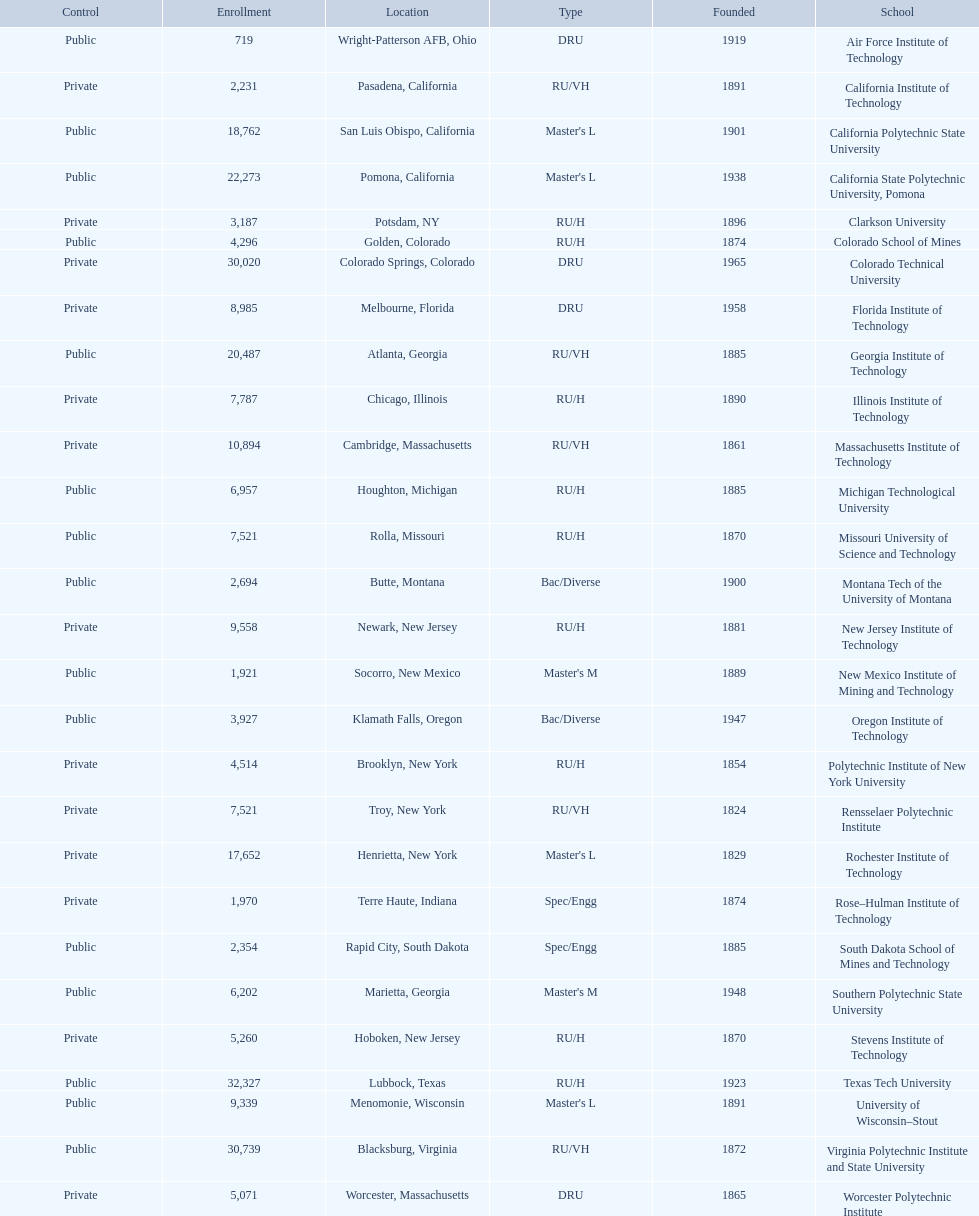What technical universities are in the united states? Air Force Institute of Technology, California Institute of Technology, California Polytechnic State University, California State Polytechnic University, Pomona, Clarkson University, Colorado School of Mines, Colorado Technical University, Florida Institute of Technology, Georgia Institute of Technology, Illinois Institute of Technology, Massachusetts Institute of Technology, Michigan Technological University, Missouri University of Science and Technology, Montana Tech of the University of Montana, New Jersey Institute of Technology, New Mexico Institute of Mining and Technology, Oregon Institute of Technology, Polytechnic Institute of New York University, Rensselaer Polytechnic Institute, Rochester Institute of Technology, Rose–Hulman Institute of Technology, South Dakota School of Mines and Technology, Southern Polytechnic State University, Stevens Institute of Technology, Texas Tech University, University of Wisconsin–Stout, Virginia Polytechnic Institute and State University, Worcester Polytechnic Institute. Which has the highest enrollment? Texas Tech University. Would you mind parsing the complete table? {'header': ['Control', 'Enrollment', 'Location', 'Type', 'Founded', 'School'], 'rows': [['Public', '719', 'Wright-Patterson AFB, Ohio', 'DRU', '1919', 'Air Force Institute of Technology'], ['Private', '2,231', 'Pasadena, California', 'RU/VH', '1891', 'California Institute of Technology'], ['Public', '18,762', 'San Luis Obispo, California', "Master's L", '1901', 'California Polytechnic State University'], ['Public', '22,273', 'Pomona, California', "Master's L", '1938', 'California State Polytechnic University, Pomona'], ['Private', '3,187', 'Potsdam, NY', 'RU/H', '1896', 'Clarkson University'], ['Public', '4,296', 'Golden, Colorado', 'RU/H', '1874', 'Colorado School of Mines'], ['Private', '30,020', 'Colorado Springs, Colorado', 'DRU', '1965', 'Colorado Technical University'], ['Private', '8,985', 'Melbourne, Florida', 'DRU', '1958', 'Florida Institute of Technology'], ['Public', '20,487', 'Atlanta, Georgia', 'RU/VH', '1885', 'Georgia Institute of Technology'], ['Private', '7,787', 'Chicago, Illinois', 'RU/H', '1890', 'Illinois Institute of Technology'], ['Private', '10,894', 'Cambridge, Massachusetts', 'RU/VH', '1861', 'Massachusetts Institute of Technology'], ['Public', '6,957', 'Houghton, Michigan', 'RU/H', '1885', 'Michigan Technological University'], ['Public', '7,521', 'Rolla, Missouri', 'RU/H', '1870', 'Missouri University of Science and Technology'], ['Public', '2,694', 'Butte, Montana', 'Bac/Diverse', '1900', 'Montana Tech of the University of Montana'], ['Private', '9,558', 'Newark, New Jersey', 'RU/H', '1881', 'New Jersey Institute of Technology'], ['Public', '1,921', 'Socorro, New Mexico', "Master's M", '1889', 'New Mexico Institute of Mining and Technology'], ['Public', '3,927', 'Klamath Falls, Oregon', 'Bac/Diverse', '1947', 'Oregon Institute of Technology'], ['Private', '4,514', 'Brooklyn, New York', 'RU/H', '1854', 'Polytechnic Institute of New York University'], ['Private', '7,521', 'Troy, New York', 'RU/VH', '1824', 'Rensselaer Polytechnic Institute'], ['Private', '17,652', 'Henrietta, New York', "Master's L", '1829', 'Rochester Institute of Technology'], ['Private', '1,970', 'Terre Haute, Indiana', 'Spec/Engg', '1874', 'Rose–Hulman Institute of Technology'], ['Public', '2,354', 'Rapid City, South Dakota', 'Spec/Engg', '1885', 'South Dakota School of Mines and Technology'], ['Public', '6,202', 'Marietta, Georgia', "Master's M", '1948', 'Southern Polytechnic State University'], ['Private', '5,260', 'Hoboken, New Jersey', 'RU/H', '1870', 'Stevens Institute of Technology'], ['Public', '32,327', 'Lubbock, Texas', 'RU/H', '1923', 'Texas Tech University'], ['Public', '9,339', 'Menomonie, Wisconsin', "Master's L", '1891', 'University of Wisconsin–Stout'], ['Public', '30,739', 'Blacksburg, Virginia', 'RU/VH', '1872', 'Virginia Polytechnic Institute and State University'], ['Private', '5,071', 'Worcester, Massachusetts', 'DRU', '1865', 'Worcester Polytechnic Institute']]} 